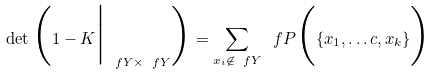<formula> <loc_0><loc_0><loc_500><loc_500>\det \Big ( 1 - K \Big | _ { \ f Y \times \ f Y } \Big ) = \sum _ { x _ { i } \not \in \ f Y } \ f P \Big ( \{ x _ { 1 } , \dots c , x _ { k } \} \Big )</formula> 